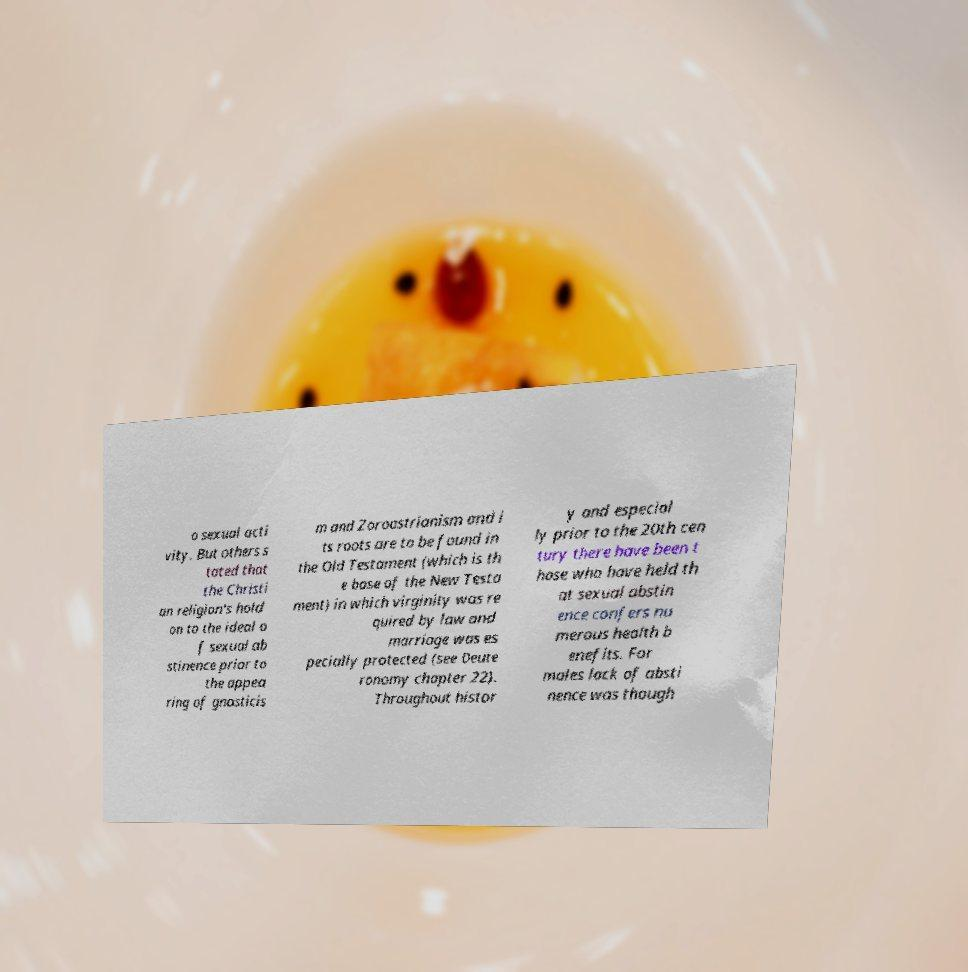Could you extract and type out the text from this image? o sexual acti vity. But others s tated that the Christi an religion's hold on to the ideal o f sexual ab stinence prior to the appea ring of gnosticis m and Zoroastrianism and i ts roots are to be found in the Old Testament (which is th e base of the New Testa ment) in which virginity was re quired by law and marriage was es pecially protected (see Deute ronomy chapter 22). Throughout histor y and especial ly prior to the 20th cen tury there have been t hose who have held th at sexual abstin ence confers nu merous health b enefits. For males lack of absti nence was though 